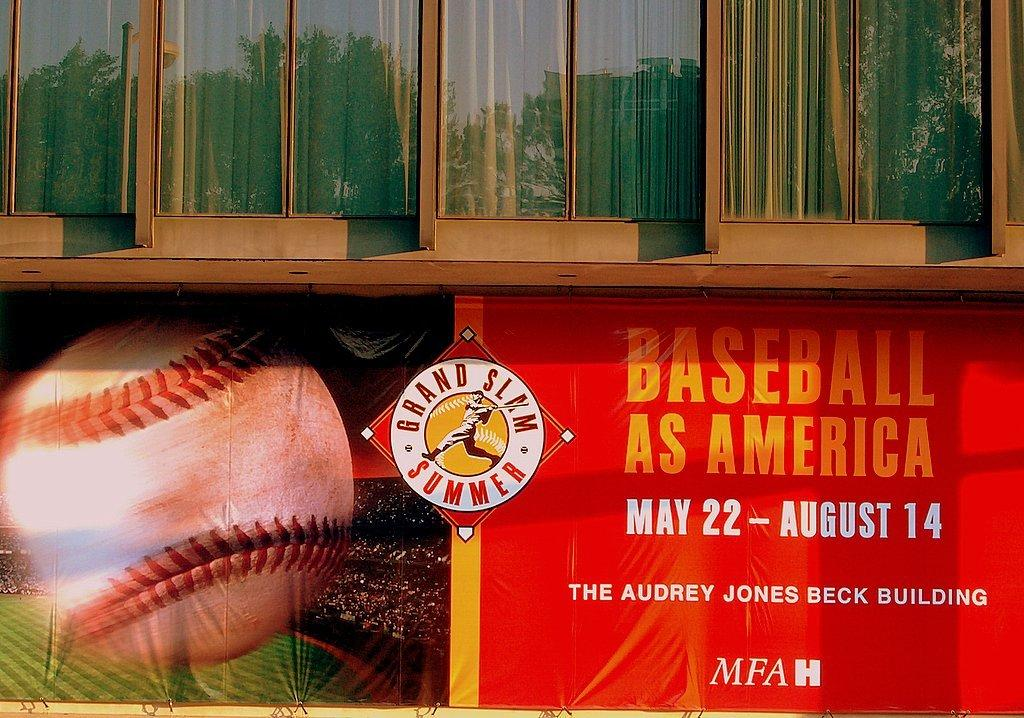What type of structure is present in the image? There is a building in the image. What feature can be observed on the building? The building has glass windows. What is hanging or attached to the building? There is a red color banner in the image. What can be seen on the banner? Something is written on the banner. Can you describe the sock that is hanging from the building in the image? There is no sock present in the image; it only features a building with glass windows and a red banner with writing on it. 